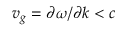Convert formula to latex. <formula><loc_0><loc_0><loc_500><loc_500>v _ { g } = \partial \omega / \partial k < c</formula> 